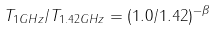<formula> <loc_0><loc_0><loc_500><loc_500>T _ { 1 G H z } / T _ { 1 . 4 2 G H z } = ( 1 . 0 / 1 . 4 2 ) ^ { - \beta }</formula> 